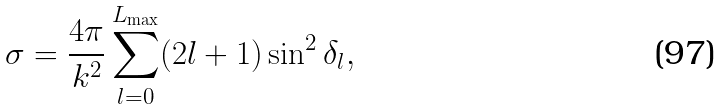Convert formula to latex. <formula><loc_0><loc_0><loc_500><loc_500>\sigma = \frac { 4 \pi } { k ^ { 2 } } \sum ^ { L _ { \max } } _ { l = 0 } ( 2 l + 1 ) \sin ^ { 2 } \delta _ { l } ,</formula> 